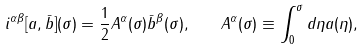Convert formula to latex. <formula><loc_0><loc_0><loc_500><loc_500>i ^ { \alpha \beta } [ a , \bar { b } ] ( \sigma ) = \frac { 1 } { 2 } { A } ^ { \alpha } ( \sigma ) { \bar { b } } ^ { \beta } ( \sigma ) , \quad A ^ { \alpha } ( \sigma ) \equiv \int _ { 0 } ^ { \sigma } d \eta a ( \eta ) ,</formula> 